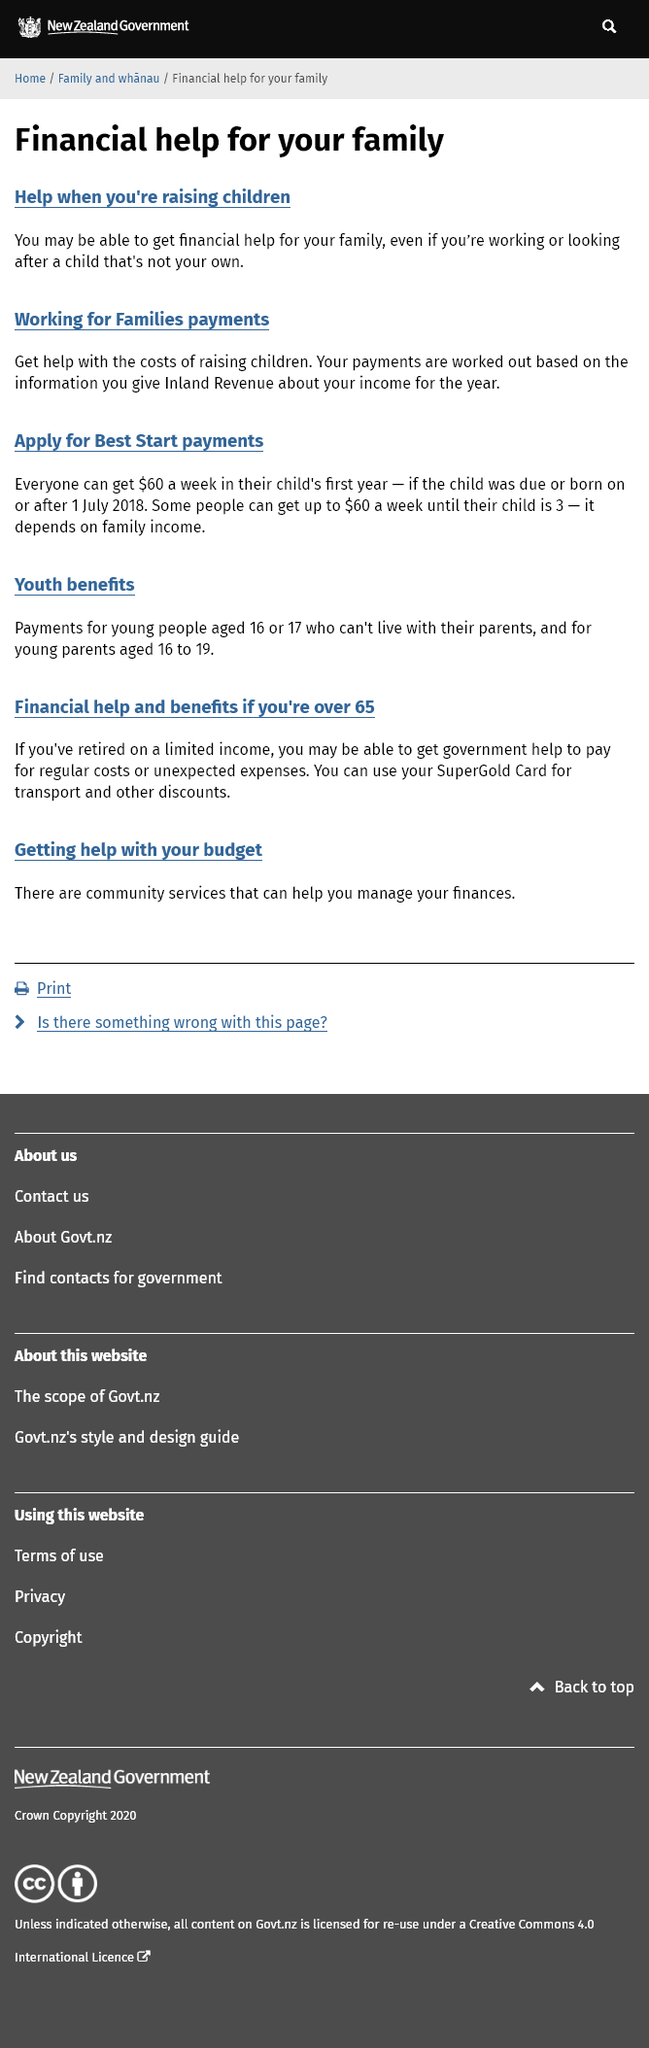Indicate a few pertinent items in this graphic. Yes, you may be eligible for financial assistance if you are responsible for caring for someone else's child. Yes, the Working for Families payments are contingent upon an individual's income. Best Start payments of $60 per week will be available to all eligible individuals. 